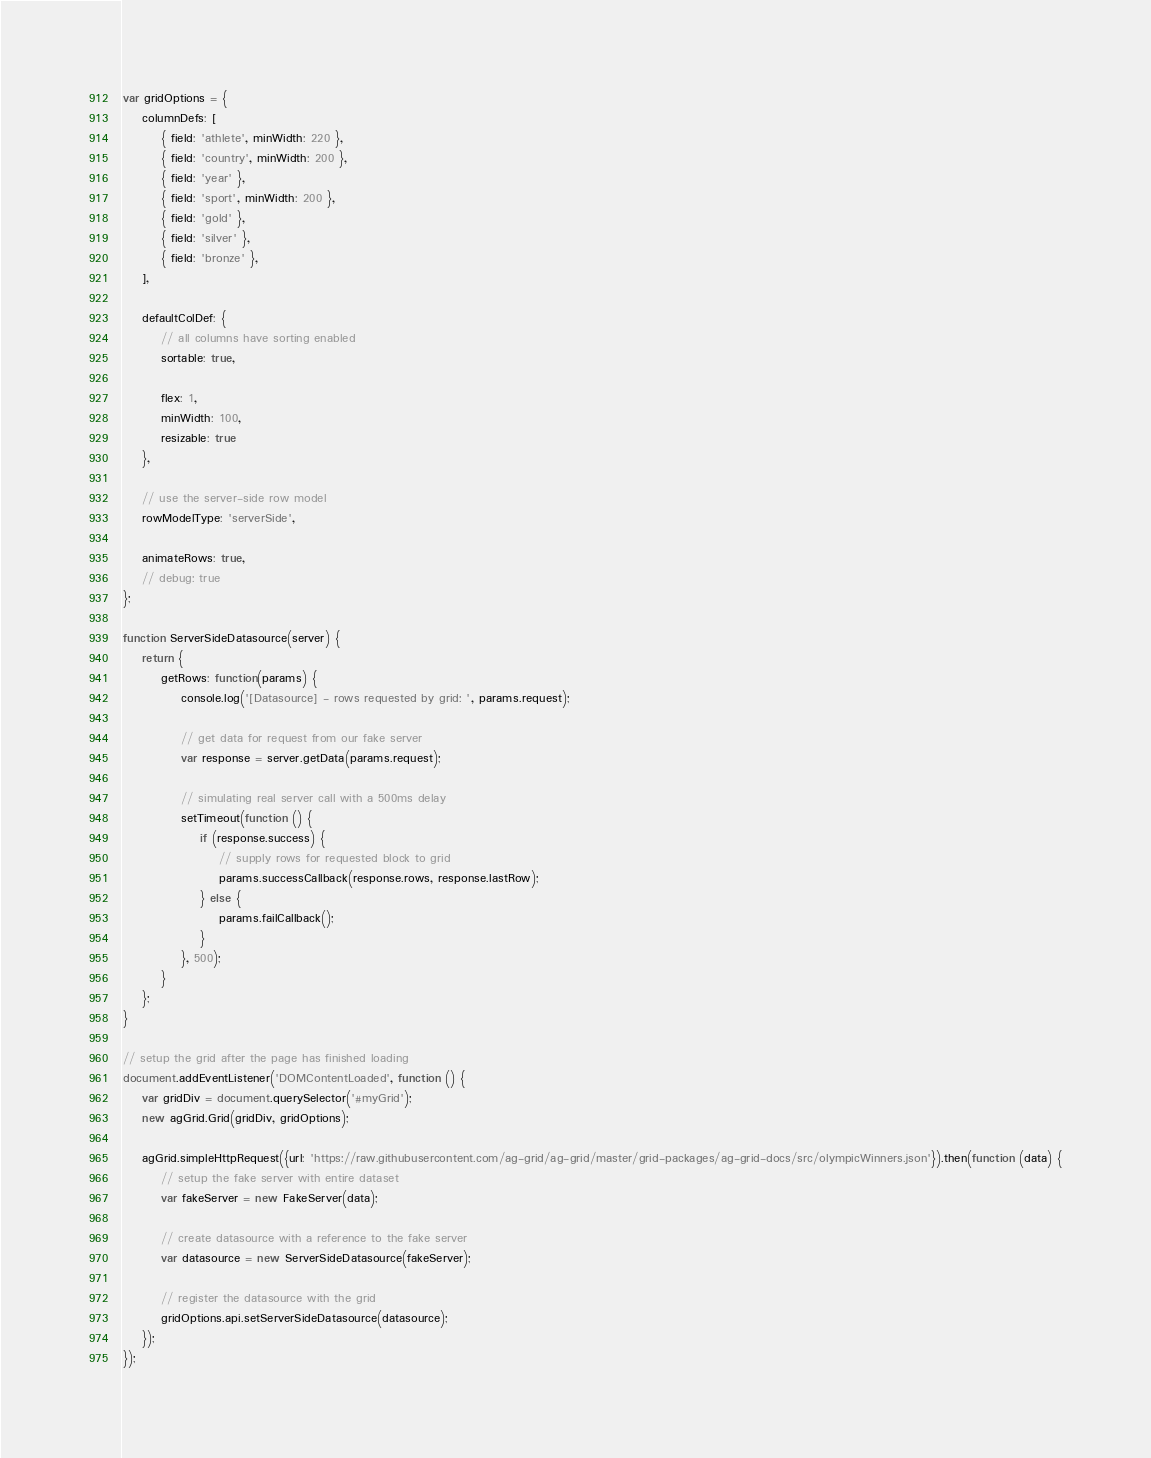<code> <loc_0><loc_0><loc_500><loc_500><_JavaScript_>var gridOptions = {
    columnDefs: [
        { field: 'athlete', minWidth: 220 },
        { field: 'country', minWidth: 200 },
        { field: 'year' },
        { field: 'sport', minWidth: 200 },
        { field: 'gold' },
        { field: 'silver' },
        { field: 'bronze' },
    ],

    defaultColDef: {
        // all columns have sorting enabled
        sortable: true,

        flex: 1,
        minWidth: 100,
        resizable: true
    },

    // use the server-side row model
    rowModelType: 'serverSide',

    animateRows: true,
    // debug: true
};

function ServerSideDatasource(server) {
    return {
        getRows: function(params) {
            console.log('[Datasource] - rows requested by grid: ', params.request);

            // get data for request from our fake server
            var response = server.getData(params.request);

            // simulating real server call with a 500ms delay
            setTimeout(function () {
                if (response.success) {
                    // supply rows for requested block to grid
                    params.successCallback(response.rows, response.lastRow);
                } else {
                    params.failCallback();
                }
            }, 500);
        }
    };
}

// setup the grid after the page has finished loading
document.addEventListener('DOMContentLoaded', function () {
    var gridDiv = document.querySelector('#myGrid');
    new agGrid.Grid(gridDiv, gridOptions);

    agGrid.simpleHttpRequest({url: 'https://raw.githubusercontent.com/ag-grid/ag-grid/master/grid-packages/ag-grid-docs/src/olympicWinners.json'}).then(function (data) {
        // setup the fake server with entire dataset
        var fakeServer = new FakeServer(data);

        // create datasource with a reference to the fake server
        var datasource = new ServerSideDatasource(fakeServer);

        // register the datasource with the grid
        gridOptions.api.setServerSideDatasource(datasource);
    });
});
</code> 